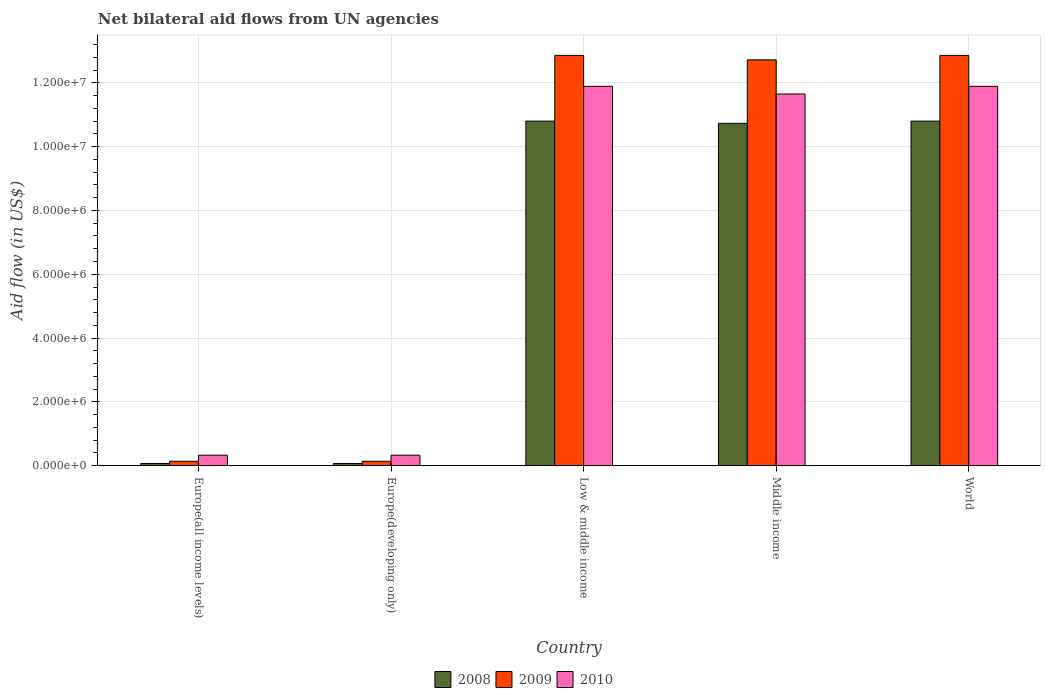Are the number of bars per tick equal to the number of legend labels?
Ensure brevity in your answer.  Yes. Are the number of bars on each tick of the X-axis equal?
Keep it short and to the point. Yes. What is the label of the 1st group of bars from the left?
Offer a very short reply. Europe(all income levels). In how many cases, is the number of bars for a given country not equal to the number of legend labels?
Offer a very short reply. 0. Across all countries, what is the maximum net bilateral aid flow in 2008?
Keep it short and to the point. 1.08e+07. In which country was the net bilateral aid flow in 2009 maximum?
Make the answer very short. Low & middle income. In which country was the net bilateral aid flow in 2008 minimum?
Ensure brevity in your answer.  Europe(all income levels). What is the total net bilateral aid flow in 2008 in the graph?
Make the answer very short. 3.25e+07. What is the difference between the net bilateral aid flow in 2009 in Low & middle income and that in Middle income?
Give a very brief answer. 1.40e+05. What is the difference between the net bilateral aid flow in 2008 in Low & middle income and the net bilateral aid flow in 2010 in Europe(all income levels)?
Give a very brief answer. 1.05e+07. What is the average net bilateral aid flow in 2009 per country?
Your answer should be compact. 7.74e+06. What is the difference between the net bilateral aid flow of/in 2010 and net bilateral aid flow of/in 2008 in Europe(developing only)?
Keep it short and to the point. 2.60e+05. What is the ratio of the net bilateral aid flow in 2008 in Europe(all income levels) to that in World?
Your response must be concise. 0.01. Is the net bilateral aid flow in 2008 in Europe(all income levels) less than that in Middle income?
Make the answer very short. Yes. Is the difference between the net bilateral aid flow in 2010 in Middle income and World greater than the difference between the net bilateral aid flow in 2008 in Middle income and World?
Ensure brevity in your answer.  No. What is the difference between the highest and the second highest net bilateral aid flow in 2008?
Your answer should be compact. 7.00e+04. What is the difference between the highest and the lowest net bilateral aid flow in 2008?
Provide a succinct answer. 1.07e+07. In how many countries, is the net bilateral aid flow in 2009 greater than the average net bilateral aid flow in 2009 taken over all countries?
Offer a very short reply. 3. Is the sum of the net bilateral aid flow in 2008 in Europe(all income levels) and World greater than the maximum net bilateral aid flow in 2010 across all countries?
Ensure brevity in your answer.  No. What does the 3rd bar from the right in Middle income represents?
Your answer should be very brief. 2008. Is it the case that in every country, the sum of the net bilateral aid flow in 2010 and net bilateral aid flow in 2008 is greater than the net bilateral aid flow in 2009?
Your response must be concise. Yes. How many bars are there?
Your response must be concise. 15. How many countries are there in the graph?
Your answer should be very brief. 5. What is the difference between two consecutive major ticks on the Y-axis?
Offer a very short reply. 2.00e+06. Does the graph contain any zero values?
Make the answer very short. No. Does the graph contain grids?
Offer a terse response. Yes. How are the legend labels stacked?
Provide a succinct answer. Horizontal. What is the title of the graph?
Make the answer very short. Net bilateral aid flows from UN agencies. Does "1967" appear as one of the legend labels in the graph?
Your response must be concise. No. What is the label or title of the Y-axis?
Your answer should be compact. Aid flow (in US$). What is the Aid flow (in US$) in 2009 in Europe(all income levels)?
Offer a terse response. 1.40e+05. What is the Aid flow (in US$) in 2008 in Europe(developing only)?
Your response must be concise. 7.00e+04. What is the Aid flow (in US$) in 2009 in Europe(developing only)?
Your answer should be very brief. 1.40e+05. What is the Aid flow (in US$) of 2008 in Low & middle income?
Your answer should be very brief. 1.08e+07. What is the Aid flow (in US$) in 2009 in Low & middle income?
Give a very brief answer. 1.29e+07. What is the Aid flow (in US$) in 2010 in Low & middle income?
Your response must be concise. 1.19e+07. What is the Aid flow (in US$) of 2008 in Middle income?
Make the answer very short. 1.07e+07. What is the Aid flow (in US$) of 2009 in Middle income?
Offer a terse response. 1.27e+07. What is the Aid flow (in US$) of 2010 in Middle income?
Ensure brevity in your answer.  1.16e+07. What is the Aid flow (in US$) of 2008 in World?
Keep it short and to the point. 1.08e+07. What is the Aid flow (in US$) of 2009 in World?
Provide a succinct answer. 1.29e+07. What is the Aid flow (in US$) in 2010 in World?
Offer a terse response. 1.19e+07. Across all countries, what is the maximum Aid flow (in US$) in 2008?
Offer a terse response. 1.08e+07. Across all countries, what is the maximum Aid flow (in US$) of 2009?
Offer a very short reply. 1.29e+07. Across all countries, what is the maximum Aid flow (in US$) in 2010?
Offer a very short reply. 1.19e+07. Across all countries, what is the minimum Aid flow (in US$) in 2008?
Provide a succinct answer. 7.00e+04. What is the total Aid flow (in US$) of 2008 in the graph?
Provide a succinct answer. 3.25e+07. What is the total Aid flow (in US$) in 2009 in the graph?
Give a very brief answer. 3.87e+07. What is the total Aid flow (in US$) of 2010 in the graph?
Offer a terse response. 3.61e+07. What is the difference between the Aid flow (in US$) in 2008 in Europe(all income levels) and that in Low & middle income?
Offer a very short reply. -1.07e+07. What is the difference between the Aid flow (in US$) in 2009 in Europe(all income levels) and that in Low & middle income?
Your answer should be compact. -1.27e+07. What is the difference between the Aid flow (in US$) of 2010 in Europe(all income levels) and that in Low & middle income?
Your response must be concise. -1.16e+07. What is the difference between the Aid flow (in US$) in 2008 in Europe(all income levels) and that in Middle income?
Make the answer very short. -1.07e+07. What is the difference between the Aid flow (in US$) of 2009 in Europe(all income levels) and that in Middle income?
Offer a very short reply. -1.26e+07. What is the difference between the Aid flow (in US$) in 2010 in Europe(all income levels) and that in Middle income?
Your answer should be compact. -1.13e+07. What is the difference between the Aid flow (in US$) in 2008 in Europe(all income levels) and that in World?
Keep it short and to the point. -1.07e+07. What is the difference between the Aid flow (in US$) in 2009 in Europe(all income levels) and that in World?
Give a very brief answer. -1.27e+07. What is the difference between the Aid flow (in US$) in 2010 in Europe(all income levels) and that in World?
Your answer should be very brief. -1.16e+07. What is the difference between the Aid flow (in US$) in 2008 in Europe(developing only) and that in Low & middle income?
Give a very brief answer. -1.07e+07. What is the difference between the Aid flow (in US$) in 2009 in Europe(developing only) and that in Low & middle income?
Give a very brief answer. -1.27e+07. What is the difference between the Aid flow (in US$) of 2010 in Europe(developing only) and that in Low & middle income?
Give a very brief answer. -1.16e+07. What is the difference between the Aid flow (in US$) in 2008 in Europe(developing only) and that in Middle income?
Ensure brevity in your answer.  -1.07e+07. What is the difference between the Aid flow (in US$) of 2009 in Europe(developing only) and that in Middle income?
Ensure brevity in your answer.  -1.26e+07. What is the difference between the Aid flow (in US$) of 2010 in Europe(developing only) and that in Middle income?
Ensure brevity in your answer.  -1.13e+07. What is the difference between the Aid flow (in US$) in 2008 in Europe(developing only) and that in World?
Your answer should be very brief. -1.07e+07. What is the difference between the Aid flow (in US$) in 2009 in Europe(developing only) and that in World?
Offer a very short reply. -1.27e+07. What is the difference between the Aid flow (in US$) of 2010 in Europe(developing only) and that in World?
Provide a short and direct response. -1.16e+07. What is the difference between the Aid flow (in US$) in 2009 in Low & middle income and that in Middle income?
Ensure brevity in your answer.  1.40e+05. What is the difference between the Aid flow (in US$) of 2010 in Low & middle income and that in Middle income?
Provide a short and direct response. 2.40e+05. What is the difference between the Aid flow (in US$) of 2009 in Europe(all income levels) and the Aid flow (in US$) of 2010 in Europe(developing only)?
Offer a terse response. -1.90e+05. What is the difference between the Aid flow (in US$) of 2008 in Europe(all income levels) and the Aid flow (in US$) of 2009 in Low & middle income?
Offer a terse response. -1.28e+07. What is the difference between the Aid flow (in US$) of 2008 in Europe(all income levels) and the Aid flow (in US$) of 2010 in Low & middle income?
Offer a very short reply. -1.18e+07. What is the difference between the Aid flow (in US$) in 2009 in Europe(all income levels) and the Aid flow (in US$) in 2010 in Low & middle income?
Ensure brevity in your answer.  -1.18e+07. What is the difference between the Aid flow (in US$) of 2008 in Europe(all income levels) and the Aid flow (in US$) of 2009 in Middle income?
Your answer should be very brief. -1.26e+07. What is the difference between the Aid flow (in US$) in 2008 in Europe(all income levels) and the Aid flow (in US$) in 2010 in Middle income?
Ensure brevity in your answer.  -1.16e+07. What is the difference between the Aid flow (in US$) of 2009 in Europe(all income levels) and the Aid flow (in US$) of 2010 in Middle income?
Your response must be concise. -1.15e+07. What is the difference between the Aid flow (in US$) in 2008 in Europe(all income levels) and the Aid flow (in US$) in 2009 in World?
Provide a succinct answer. -1.28e+07. What is the difference between the Aid flow (in US$) in 2008 in Europe(all income levels) and the Aid flow (in US$) in 2010 in World?
Your answer should be very brief. -1.18e+07. What is the difference between the Aid flow (in US$) of 2009 in Europe(all income levels) and the Aid flow (in US$) of 2010 in World?
Keep it short and to the point. -1.18e+07. What is the difference between the Aid flow (in US$) of 2008 in Europe(developing only) and the Aid flow (in US$) of 2009 in Low & middle income?
Make the answer very short. -1.28e+07. What is the difference between the Aid flow (in US$) of 2008 in Europe(developing only) and the Aid flow (in US$) of 2010 in Low & middle income?
Provide a short and direct response. -1.18e+07. What is the difference between the Aid flow (in US$) in 2009 in Europe(developing only) and the Aid flow (in US$) in 2010 in Low & middle income?
Your answer should be very brief. -1.18e+07. What is the difference between the Aid flow (in US$) in 2008 in Europe(developing only) and the Aid flow (in US$) in 2009 in Middle income?
Ensure brevity in your answer.  -1.26e+07. What is the difference between the Aid flow (in US$) of 2008 in Europe(developing only) and the Aid flow (in US$) of 2010 in Middle income?
Make the answer very short. -1.16e+07. What is the difference between the Aid flow (in US$) in 2009 in Europe(developing only) and the Aid flow (in US$) in 2010 in Middle income?
Ensure brevity in your answer.  -1.15e+07. What is the difference between the Aid flow (in US$) in 2008 in Europe(developing only) and the Aid flow (in US$) in 2009 in World?
Your answer should be very brief. -1.28e+07. What is the difference between the Aid flow (in US$) in 2008 in Europe(developing only) and the Aid flow (in US$) in 2010 in World?
Offer a very short reply. -1.18e+07. What is the difference between the Aid flow (in US$) in 2009 in Europe(developing only) and the Aid flow (in US$) in 2010 in World?
Provide a short and direct response. -1.18e+07. What is the difference between the Aid flow (in US$) in 2008 in Low & middle income and the Aid flow (in US$) in 2009 in Middle income?
Offer a terse response. -1.92e+06. What is the difference between the Aid flow (in US$) of 2008 in Low & middle income and the Aid flow (in US$) of 2010 in Middle income?
Your response must be concise. -8.50e+05. What is the difference between the Aid flow (in US$) in 2009 in Low & middle income and the Aid flow (in US$) in 2010 in Middle income?
Your response must be concise. 1.21e+06. What is the difference between the Aid flow (in US$) of 2008 in Low & middle income and the Aid flow (in US$) of 2009 in World?
Your answer should be compact. -2.06e+06. What is the difference between the Aid flow (in US$) of 2008 in Low & middle income and the Aid flow (in US$) of 2010 in World?
Offer a very short reply. -1.09e+06. What is the difference between the Aid flow (in US$) in 2009 in Low & middle income and the Aid flow (in US$) in 2010 in World?
Your response must be concise. 9.70e+05. What is the difference between the Aid flow (in US$) of 2008 in Middle income and the Aid flow (in US$) of 2009 in World?
Your answer should be compact. -2.13e+06. What is the difference between the Aid flow (in US$) in 2008 in Middle income and the Aid flow (in US$) in 2010 in World?
Your answer should be compact. -1.16e+06. What is the difference between the Aid flow (in US$) in 2009 in Middle income and the Aid flow (in US$) in 2010 in World?
Keep it short and to the point. 8.30e+05. What is the average Aid flow (in US$) in 2008 per country?
Your answer should be compact. 6.49e+06. What is the average Aid flow (in US$) in 2009 per country?
Your answer should be very brief. 7.74e+06. What is the average Aid flow (in US$) of 2010 per country?
Offer a very short reply. 7.22e+06. What is the difference between the Aid flow (in US$) of 2008 and Aid flow (in US$) of 2010 in Europe(all income levels)?
Your response must be concise. -2.60e+05. What is the difference between the Aid flow (in US$) in 2009 and Aid flow (in US$) in 2010 in Europe(all income levels)?
Give a very brief answer. -1.90e+05. What is the difference between the Aid flow (in US$) in 2008 and Aid flow (in US$) in 2010 in Europe(developing only)?
Your answer should be compact. -2.60e+05. What is the difference between the Aid flow (in US$) in 2008 and Aid flow (in US$) in 2009 in Low & middle income?
Your answer should be compact. -2.06e+06. What is the difference between the Aid flow (in US$) in 2008 and Aid flow (in US$) in 2010 in Low & middle income?
Give a very brief answer. -1.09e+06. What is the difference between the Aid flow (in US$) of 2009 and Aid flow (in US$) of 2010 in Low & middle income?
Offer a very short reply. 9.70e+05. What is the difference between the Aid flow (in US$) in 2008 and Aid flow (in US$) in 2009 in Middle income?
Your response must be concise. -1.99e+06. What is the difference between the Aid flow (in US$) in 2008 and Aid flow (in US$) in 2010 in Middle income?
Make the answer very short. -9.20e+05. What is the difference between the Aid flow (in US$) in 2009 and Aid flow (in US$) in 2010 in Middle income?
Offer a terse response. 1.07e+06. What is the difference between the Aid flow (in US$) of 2008 and Aid flow (in US$) of 2009 in World?
Provide a succinct answer. -2.06e+06. What is the difference between the Aid flow (in US$) in 2008 and Aid flow (in US$) in 2010 in World?
Your response must be concise. -1.09e+06. What is the difference between the Aid flow (in US$) of 2009 and Aid flow (in US$) of 2010 in World?
Your answer should be compact. 9.70e+05. What is the ratio of the Aid flow (in US$) of 2008 in Europe(all income levels) to that in Europe(developing only)?
Your answer should be very brief. 1. What is the ratio of the Aid flow (in US$) in 2010 in Europe(all income levels) to that in Europe(developing only)?
Provide a short and direct response. 1. What is the ratio of the Aid flow (in US$) in 2008 in Europe(all income levels) to that in Low & middle income?
Offer a terse response. 0.01. What is the ratio of the Aid flow (in US$) of 2009 in Europe(all income levels) to that in Low & middle income?
Keep it short and to the point. 0.01. What is the ratio of the Aid flow (in US$) in 2010 in Europe(all income levels) to that in Low & middle income?
Offer a terse response. 0.03. What is the ratio of the Aid flow (in US$) of 2008 in Europe(all income levels) to that in Middle income?
Ensure brevity in your answer.  0.01. What is the ratio of the Aid flow (in US$) of 2009 in Europe(all income levels) to that in Middle income?
Make the answer very short. 0.01. What is the ratio of the Aid flow (in US$) in 2010 in Europe(all income levels) to that in Middle income?
Make the answer very short. 0.03. What is the ratio of the Aid flow (in US$) in 2008 in Europe(all income levels) to that in World?
Keep it short and to the point. 0.01. What is the ratio of the Aid flow (in US$) in 2009 in Europe(all income levels) to that in World?
Your response must be concise. 0.01. What is the ratio of the Aid flow (in US$) of 2010 in Europe(all income levels) to that in World?
Your response must be concise. 0.03. What is the ratio of the Aid flow (in US$) in 2008 in Europe(developing only) to that in Low & middle income?
Your answer should be compact. 0.01. What is the ratio of the Aid flow (in US$) of 2009 in Europe(developing only) to that in Low & middle income?
Offer a terse response. 0.01. What is the ratio of the Aid flow (in US$) in 2010 in Europe(developing only) to that in Low & middle income?
Offer a very short reply. 0.03. What is the ratio of the Aid flow (in US$) of 2008 in Europe(developing only) to that in Middle income?
Give a very brief answer. 0.01. What is the ratio of the Aid flow (in US$) in 2009 in Europe(developing only) to that in Middle income?
Give a very brief answer. 0.01. What is the ratio of the Aid flow (in US$) of 2010 in Europe(developing only) to that in Middle income?
Give a very brief answer. 0.03. What is the ratio of the Aid flow (in US$) in 2008 in Europe(developing only) to that in World?
Your response must be concise. 0.01. What is the ratio of the Aid flow (in US$) of 2009 in Europe(developing only) to that in World?
Provide a succinct answer. 0.01. What is the ratio of the Aid flow (in US$) in 2010 in Europe(developing only) to that in World?
Offer a very short reply. 0.03. What is the ratio of the Aid flow (in US$) in 2008 in Low & middle income to that in Middle income?
Your response must be concise. 1.01. What is the ratio of the Aid flow (in US$) of 2009 in Low & middle income to that in Middle income?
Offer a terse response. 1.01. What is the ratio of the Aid flow (in US$) in 2010 in Low & middle income to that in Middle income?
Your response must be concise. 1.02. What is the ratio of the Aid flow (in US$) in 2009 in Low & middle income to that in World?
Your answer should be very brief. 1. What is the ratio of the Aid flow (in US$) of 2008 in Middle income to that in World?
Give a very brief answer. 0.99. What is the ratio of the Aid flow (in US$) in 2010 in Middle income to that in World?
Your response must be concise. 0.98. What is the difference between the highest and the second highest Aid flow (in US$) in 2009?
Keep it short and to the point. 0. What is the difference between the highest and the second highest Aid flow (in US$) in 2010?
Keep it short and to the point. 0. What is the difference between the highest and the lowest Aid flow (in US$) of 2008?
Your response must be concise. 1.07e+07. What is the difference between the highest and the lowest Aid flow (in US$) in 2009?
Offer a terse response. 1.27e+07. What is the difference between the highest and the lowest Aid flow (in US$) of 2010?
Provide a succinct answer. 1.16e+07. 